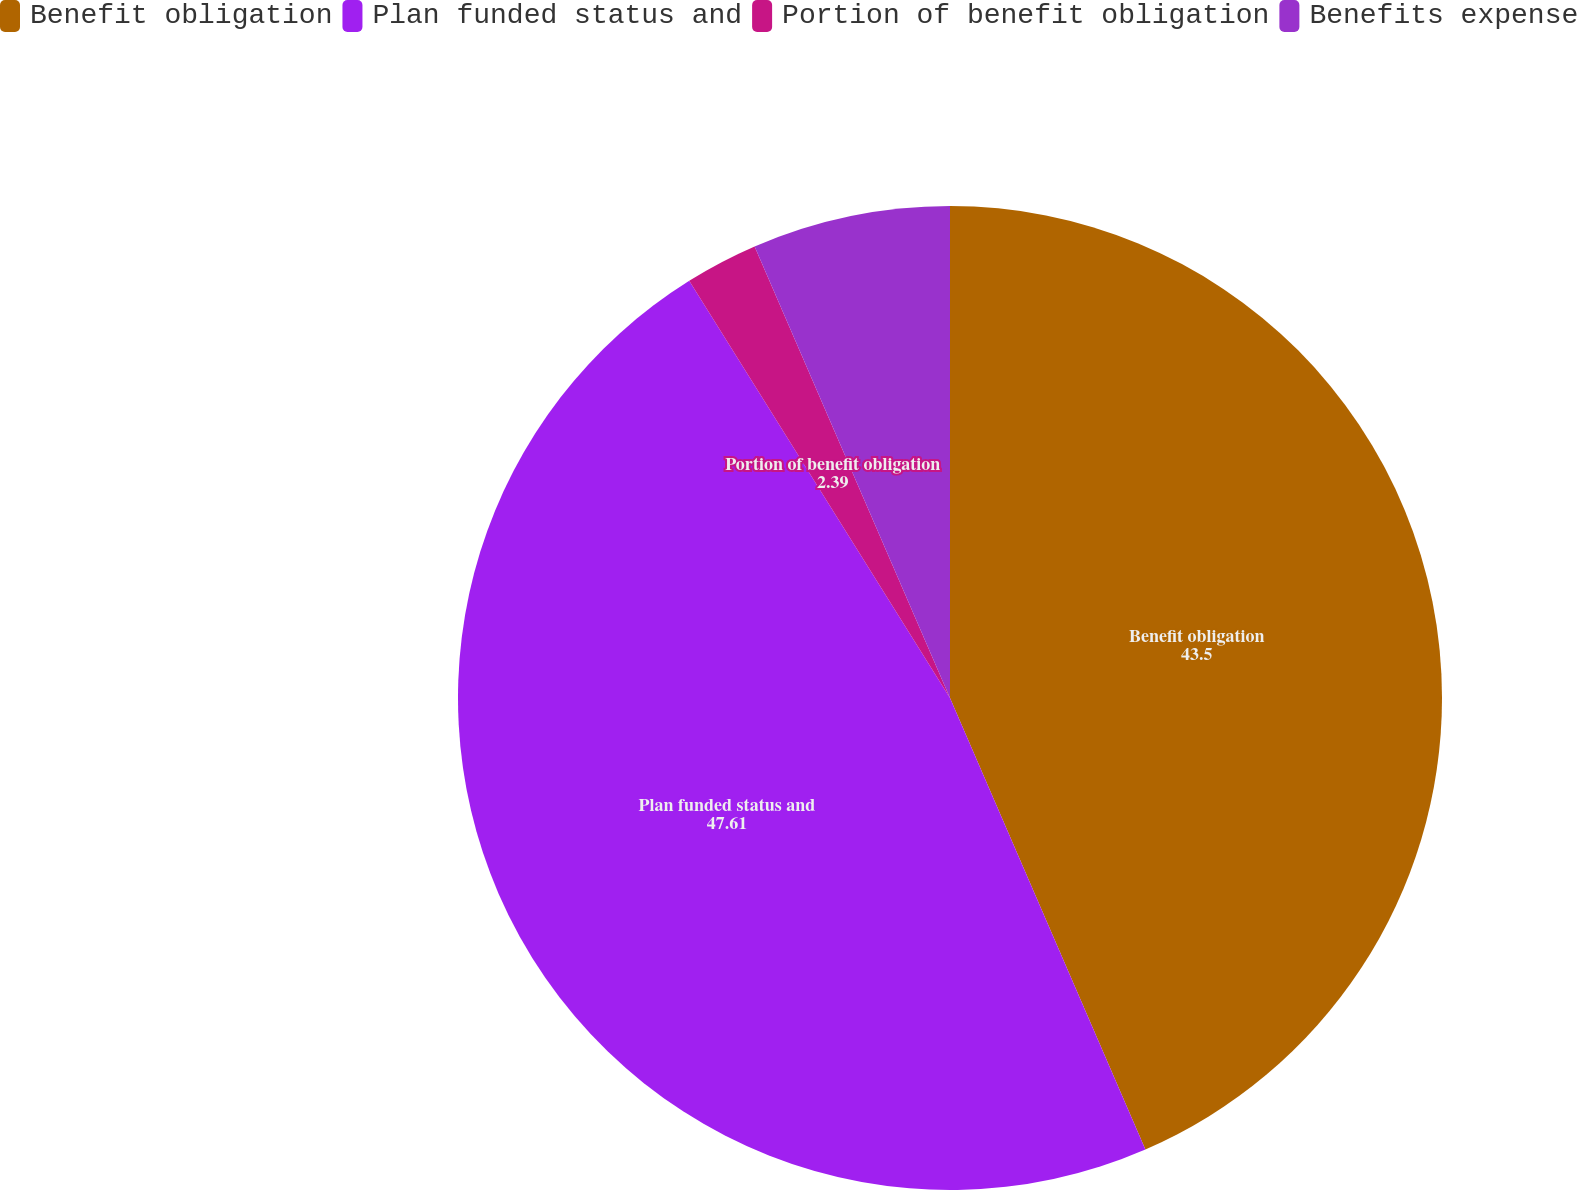Convert chart. <chart><loc_0><loc_0><loc_500><loc_500><pie_chart><fcel>Benefit obligation<fcel>Plan funded status and<fcel>Portion of benefit obligation<fcel>Benefits expense<nl><fcel>43.5%<fcel>47.61%<fcel>2.39%<fcel>6.5%<nl></chart> 